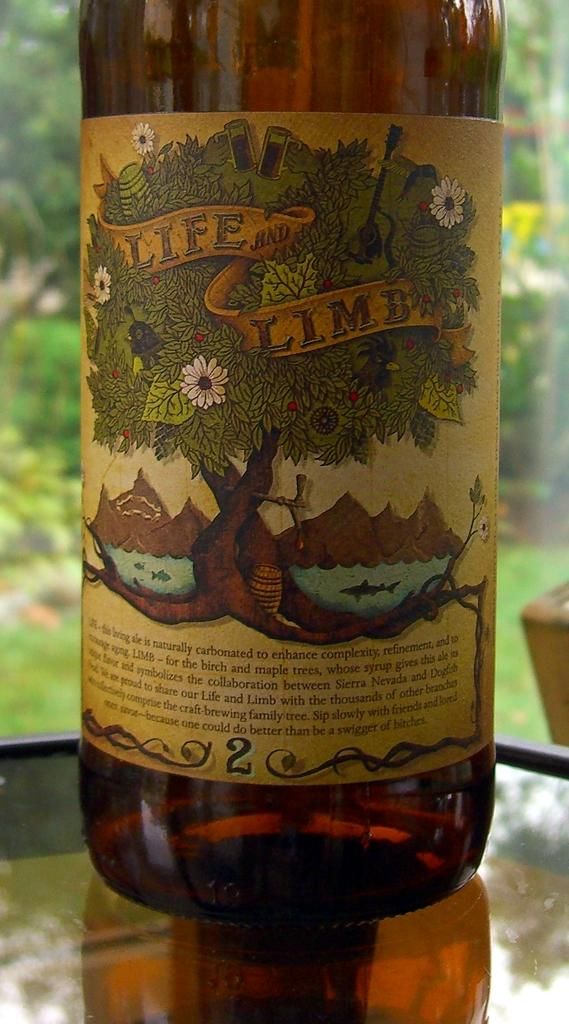What object is placed on the table in the image? There is a bottle on a table in the image. What can be observed on the bottle? The bottle has different types of stickers. What can be seen in the distance behind the table? There is a tree visible in the background. What type of oranges can be seen hanging from the tree in the image? There are no oranges or trees with fruit in the image; it only shows a bottle with stickers on a table. 